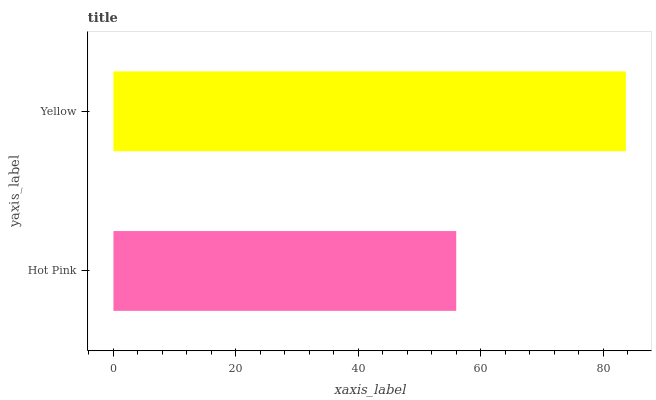Is Hot Pink the minimum?
Answer yes or no. Yes. Is Yellow the maximum?
Answer yes or no. Yes. Is Yellow the minimum?
Answer yes or no. No. Is Yellow greater than Hot Pink?
Answer yes or no. Yes. Is Hot Pink less than Yellow?
Answer yes or no. Yes. Is Hot Pink greater than Yellow?
Answer yes or no. No. Is Yellow less than Hot Pink?
Answer yes or no. No. Is Yellow the high median?
Answer yes or no. Yes. Is Hot Pink the low median?
Answer yes or no. Yes. Is Hot Pink the high median?
Answer yes or no. No. Is Yellow the low median?
Answer yes or no. No. 